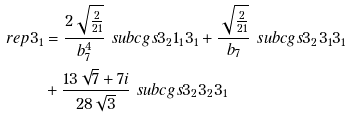<formula> <loc_0><loc_0><loc_500><loc_500>\ r e p { 3 } _ { 1 } & = \frac { 2 \sqrt { \frac { 2 } { 2 1 } } } { b _ { 7 } ^ { 4 } } \ s u b c g s { 3 _ { 2 } } { 1 _ { 1 } } { 3 _ { 1 } } + \frac { \sqrt { \frac { 2 } { 2 1 } } } { b _ { 7 } } \ s u b c g s { 3 _ { 2 } } { 3 _ { 1 } } { 3 _ { 1 } } \\ & + \frac { 1 3 \sqrt { 7 } + 7 i } { 2 8 \sqrt { 3 } } \ s u b c g s { 3 _ { 2 } } { 3 _ { 2 } } { 3 _ { 1 } }</formula> 